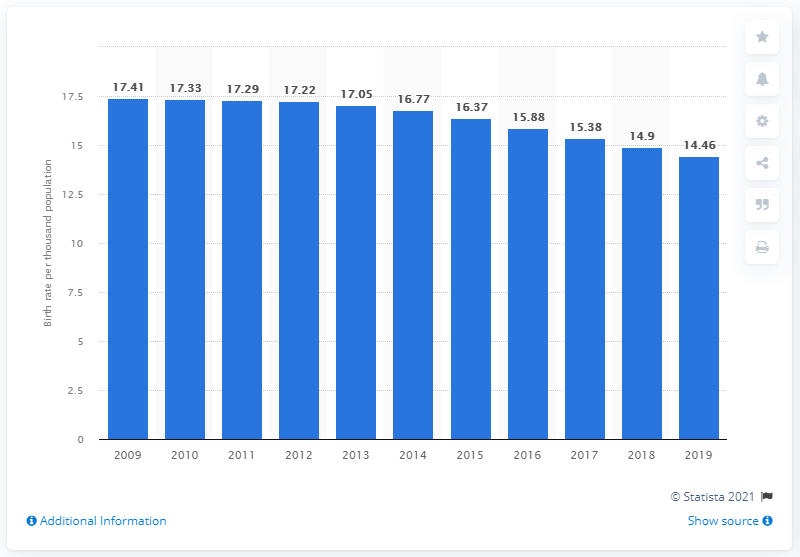Give some essential details in this illustration. The crude birth rate in Brunei Darussalam in 2019 was 14.46. 